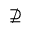Convert formula to latex. <formula><loc_0><loc_0><loc_500><loc_500>\nsupseteq</formula> 